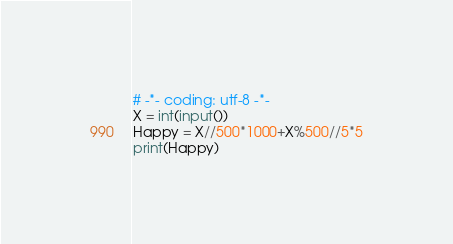<code> <loc_0><loc_0><loc_500><loc_500><_Python_># -*- coding: utf-8 -*-
X = int(input())
Happy = X//500*1000+X%500//5*5
print(Happy)</code> 